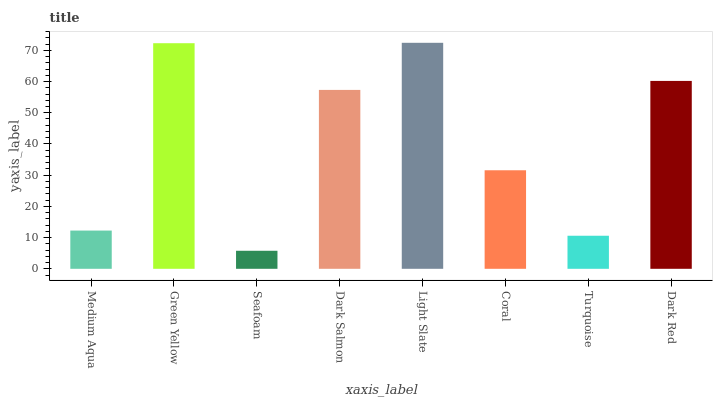Is Seafoam the minimum?
Answer yes or no. Yes. Is Light Slate the maximum?
Answer yes or no. Yes. Is Green Yellow the minimum?
Answer yes or no. No. Is Green Yellow the maximum?
Answer yes or no. No. Is Green Yellow greater than Medium Aqua?
Answer yes or no. Yes. Is Medium Aqua less than Green Yellow?
Answer yes or no. Yes. Is Medium Aqua greater than Green Yellow?
Answer yes or no. No. Is Green Yellow less than Medium Aqua?
Answer yes or no. No. Is Dark Salmon the high median?
Answer yes or no. Yes. Is Coral the low median?
Answer yes or no. Yes. Is Coral the high median?
Answer yes or no. No. Is Dark Red the low median?
Answer yes or no. No. 